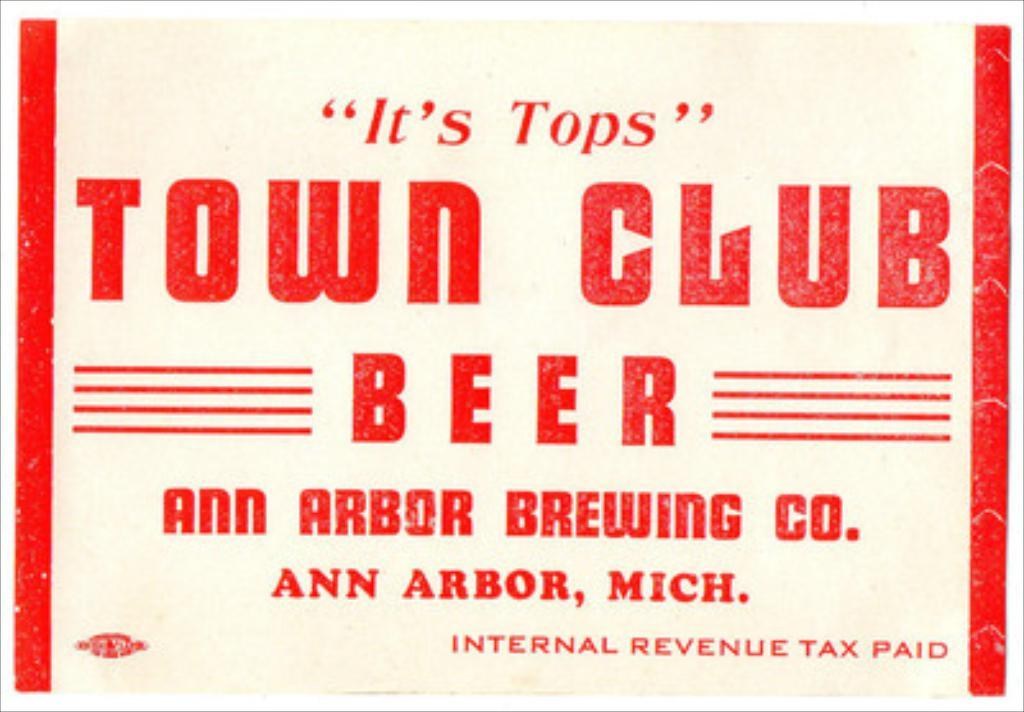<image>
Offer a succinct explanation of the picture presented. Sign that says "Town Club Beer" from Ann Arbor. 